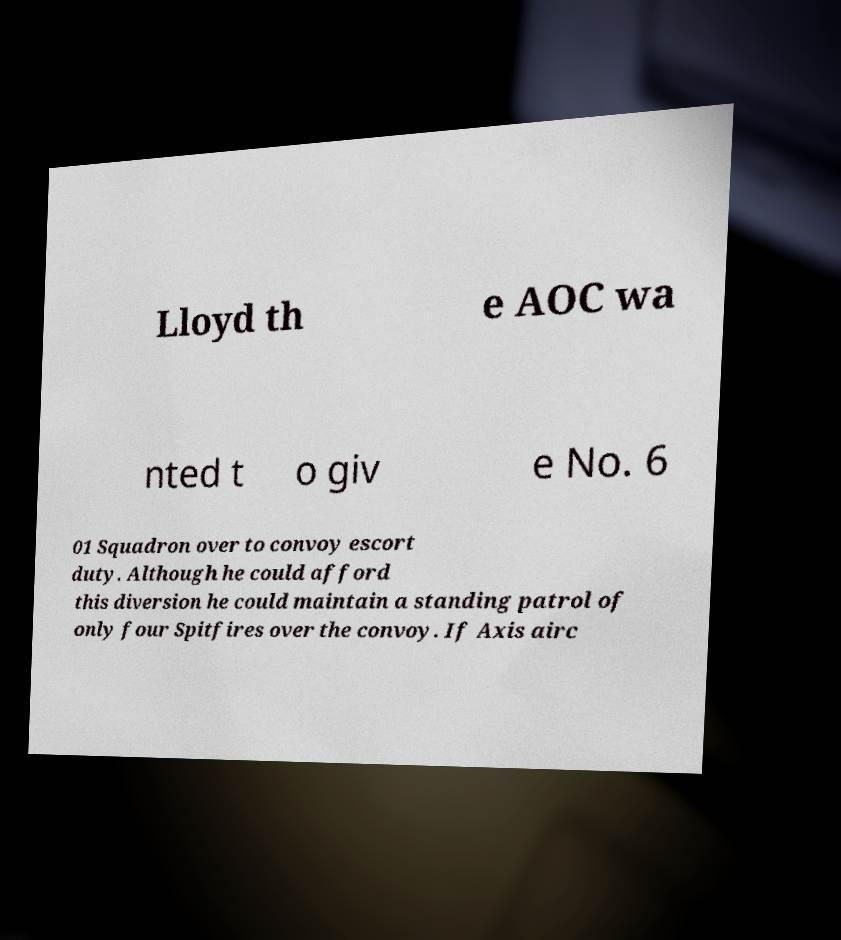Please identify and transcribe the text found in this image. Lloyd th e AOC wa nted t o giv e No. 6 01 Squadron over to convoy escort duty. Although he could afford this diversion he could maintain a standing patrol of only four Spitfires over the convoy. If Axis airc 